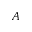<formula> <loc_0><loc_0><loc_500><loc_500>A</formula> 